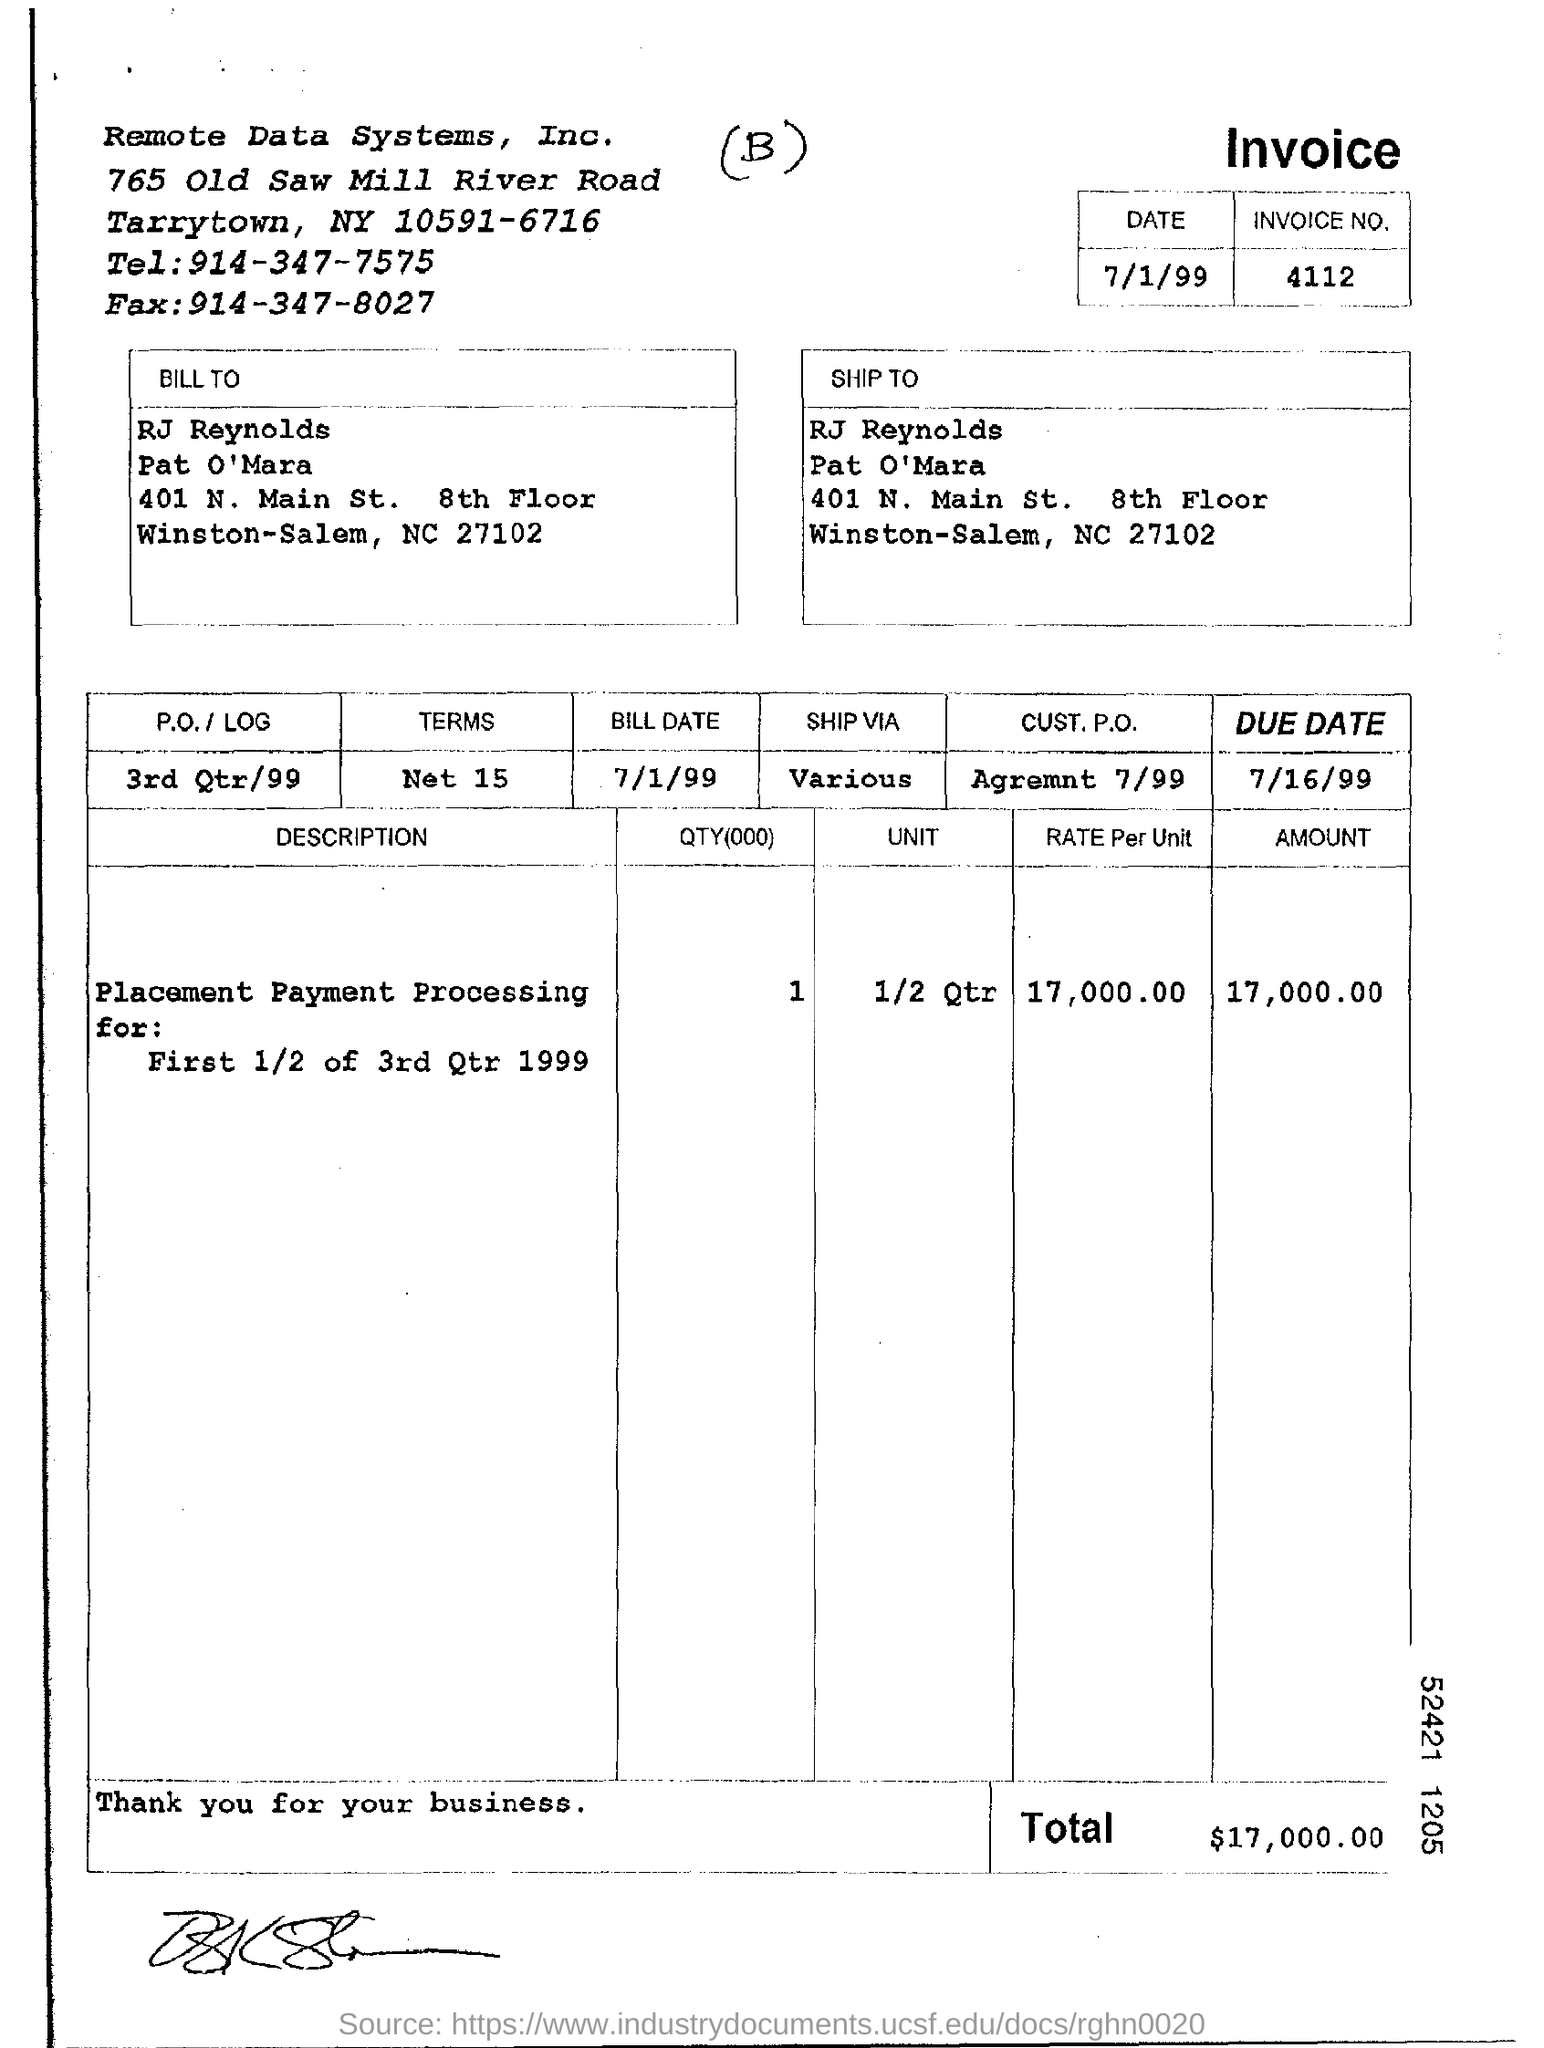Point out several critical features in this image. The invoice number is 4112. The due date is July 16, 1999. The bill date is July 1, 1999. The total amount mentioned in the invoice is 17,000.00. 